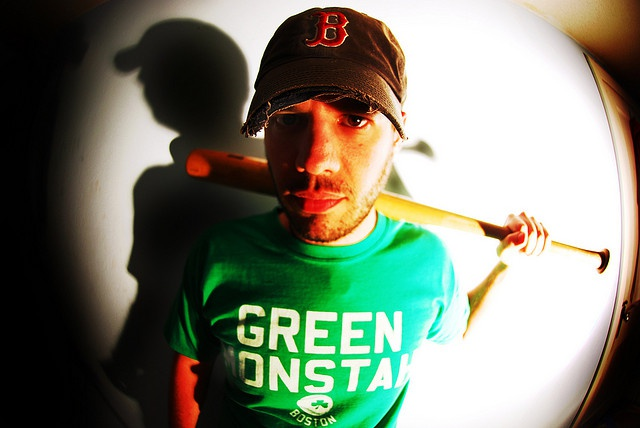Describe the objects in this image and their specific colors. I can see people in black, white, aquamarine, and darkgreen tones and baseball bat in black, ivory, maroon, and khaki tones in this image. 